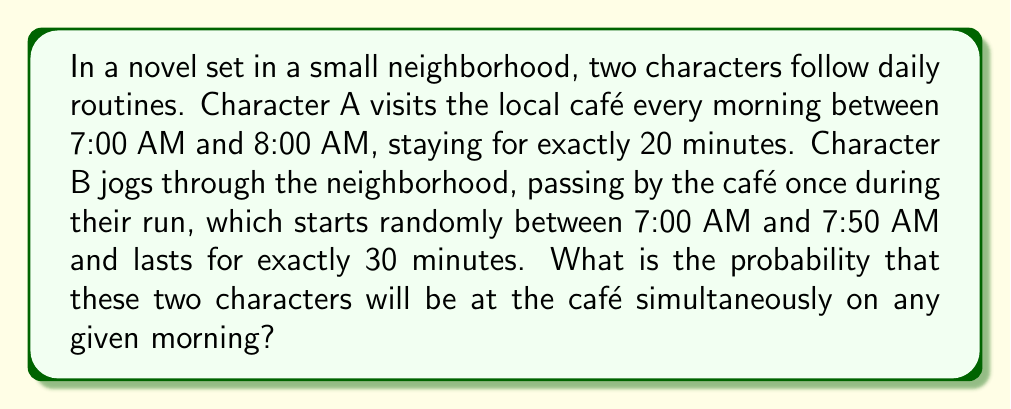Teach me how to tackle this problem. To solve this problem, we need to calculate the probability of the two characters being at the café at the same time. Let's break it down step-by-step:

1. Character A's visit:
   - Arrives between 7:00 AM and 8:00 AM
   - Stays for 20 minutes

2. Character B's jog:
   - Starts between 7:00 AM and 7:50 AM
   - Lasts for 30 minutes

3. We need to find the probability of overlap. Let's define some variables:
   $t_A$: Character A's arrival time (in minutes after 7:00 AM)
   $t_B$: Character B's start time (in minutes after 7:00 AM)

4. The total possible time range for both characters is 60 minutes (7:00 AM to 8:00 AM).

5. For an overlap to occur, Character B must pass the café while Character A is there. This means:
   $t_A \leq t_B < t_A + 20$

6. The probability of this happening is the area of the region satisfying this inequality divided by the total area of possible outcomes.

7. We can visualize this as a rectangle in the $(t_A, t_B)$ plane:

[asy]
unitsize(2mm);
draw((0,0)--(60,0)--(60,50)--(0,50)--cycle);
fill((0,0)--(50,0)--(50,20)--(20,20)--(0,0), gray(0.7));
label("$t_A$", (60,-3));
label("$t_B$", (-3,50));
label("60", (60,-3));
label("50", (-3,50));
[/asy]

8. The total area of possible outcomes is:
   $A_{total} = 60 \times 50 = 3000$ square minutes

9. The area of the overlap region (shaded triangle) is:
   $A_{overlap} = \frac{1}{2} \times 50 \times 20 = 500$ square minutes

10. The probability is therefore:
    $$P(\text{overlap}) = \frac{A_{overlap}}{A_{total}} = \frac{500}{3000} = \frac{1}{6}$$
Answer: The probability that the two characters will be at the café simultaneously on any given morning is $\frac{1}{6}$ or approximately $0.1667$. 